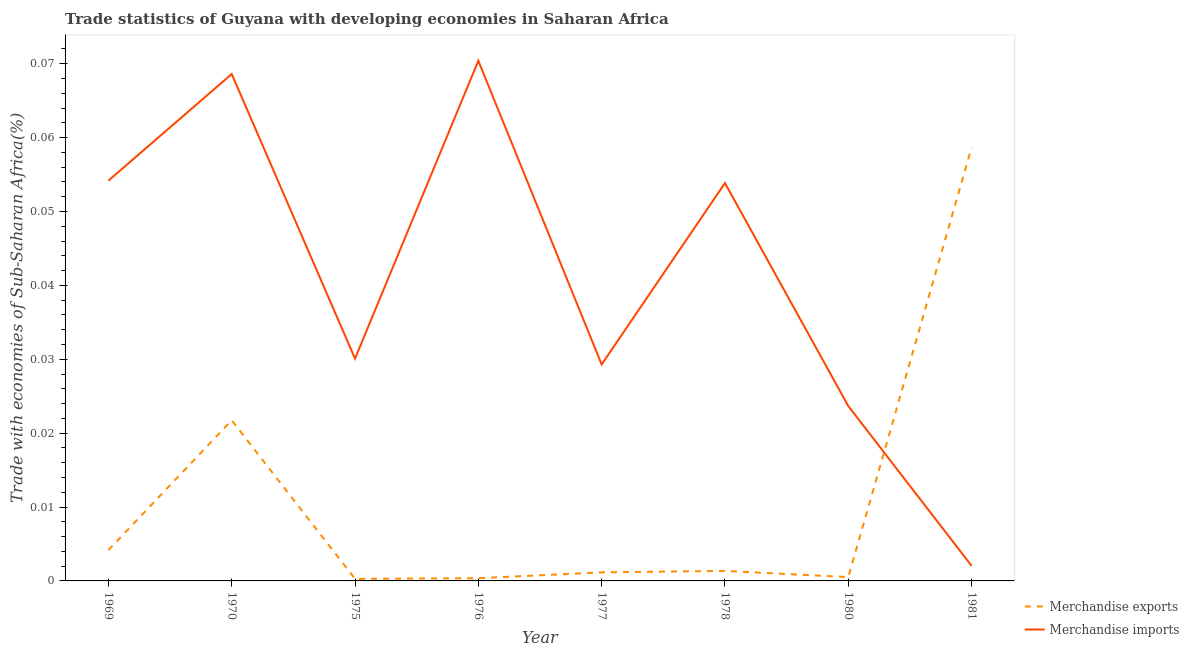Is the number of lines equal to the number of legend labels?
Ensure brevity in your answer.  Yes. What is the merchandise exports in 1981?
Provide a short and direct response. 0.06. Across all years, what is the maximum merchandise imports?
Provide a short and direct response. 0.07. Across all years, what is the minimum merchandise imports?
Your response must be concise. 0. What is the total merchandise imports in the graph?
Your answer should be very brief. 0.33. What is the difference between the merchandise imports in 1969 and that in 1981?
Your response must be concise. 0.05. What is the difference between the merchandise imports in 1975 and the merchandise exports in 1970?
Provide a short and direct response. 0.01. What is the average merchandise imports per year?
Provide a succinct answer. 0.04. In the year 1976, what is the difference between the merchandise exports and merchandise imports?
Ensure brevity in your answer.  -0.07. What is the ratio of the merchandise imports in 1969 to that in 1976?
Keep it short and to the point. 0.77. What is the difference between the highest and the second highest merchandise imports?
Ensure brevity in your answer.  0. What is the difference between the highest and the lowest merchandise imports?
Provide a succinct answer. 0.07. Does the merchandise imports monotonically increase over the years?
Provide a short and direct response. No. Is the merchandise exports strictly less than the merchandise imports over the years?
Provide a succinct answer. No. How many lines are there?
Make the answer very short. 2. How many years are there in the graph?
Your response must be concise. 8. What is the difference between two consecutive major ticks on the Y-axis?
Ensure brevity in your answer.  0.01. Are the values on the major ticks of Y-axis written in scientific E-notation?
Your answer should be compact. No. Does the graph contain any zero values?
Offer a very short reply. No. Does the graph contain grids?
Provide a short and direct response. No. How many legend labels are there?
Keep it short and to the point. 2. What is the title of the graph?
Provide a succinct answer. Trade statistics of Guyana with developing economies in Saharan Africa. What is the label or title of the X-axis?
Your answer should be very brief. Year. What is the label or title of the Y-axis?
Ensure brevity in your answer.  Trade with economies of Sub-Saharan Africa(%). What is the Trade with economies of Sub-Saharan Africa(%) in Merchandise exports in 1969?
Offer a terse response. 0. What is the Trade with economies of Sub-Saharan Africa(%) of Merchandise imports in 1969?
Provide a short and direct response. 0.05. What is the Trade with economies of Sub-Saharan Africa(%) of Merchandise exports in 1970?
Provide a succinct answer. 0.02. What is the Trade with economies of Sub-Saharan Africa(%) of Merchandise imports in 1970?
Ensure brevity in your answer.  0.07. What is the Trade with economies of Sub-Saharan Africa(%) in Merchandise exports in 1975?
Provide a short and direct response. 0. What is the Trade with economies of Sub-Saharan Africa(%) of Merchandise imports in 1975?
Your answer should be compact. 0.03. What is the Trade with economies of Sub-Saharan Africa(%) in Merchandise exports in 1976?
Your answer should be compact. 0. What is the Trade with economies of Sub-Saharan Africa(%) of Merchandise imports in 1976?
Your response must be concise. 0.07. What is the Trade with economies of Sub-Saharan Africa(%) of Merchandise exports in 1977?
Provide a short and direct response. 0. What is the Trade with economies of Sub-Saharan Africa(%) in Merchandise imports in 1977?
Offer a terse response. 0.03. What is the Trade with economies of Sub-Saharan Africa(%) of Merchandise exports in 1978?
Provide a short and direct response. 0. What is the Trade with economies of Sub-Saharan Africa(%) of Merchandise imports in 1978?
Provide a succinct answer. 0.05. What is the Trade with economies of Sub-Saharan Africa(%) in Merchandise exports in 1980?
Your answer should be compact. 0. What is the Trade with economies of Sub-Saharan Africa(%) in Merchandise imports in 1980?
Make the answer very short. 0.02. What is the Trade with economies of Sub-Saharan Africa(%) in Merchandise exports in 1981?
Your answer should be very brief. 0.06. What is the Trade with economies of Sub-Saharan Africa(%) of Merchandise imports in 1981?
Provide a short and direct response. 0. Across all years, what is the maximum Trade with economies of Sub-Saharan Africa(%) of Merchandise exports?
Keep it short and to the point. 0.06. Across all years, what is the maximum Trade with economies of Sub-Saharan Africa(%) in Merchandise imports?
Ensure brevity in your answer.  0.07. Across all years, what is the minimum Trade with economies of Sub-Saharan Africa(%) of Merchandise exports?
Provide a short and direct response. 0. Across all years, what is the minimum Trade with economies of Sub-Saharan Africa(%) in Merchandise imports?
Offer a terse response. 0. What is the total Trade with economies of Sub-Saharan Africa(%) in Merchandise exports in the graph?
Ensure brevity in your answer.  0.09. What is the total Trade with economies of Sub-Saharan Africa(%) in Merchandise imports in the graph?
Provide a short and direct response. 0.33. What is the difference between the Trade with economies of Sub-Saharan Africa(%) in Merchandise exports in 1969 and that in 1970?
Give a very brief answer. -0.02. What is the difference between the Trade with economies of Sub-Saharan Africa(%) of Merchandise imports in 1969 and that in 1970?
Offer a terse response. -0.01. What is the difference between the Trade with economies of Sub-Saharan Africa(%) in Merchandise exports in 1969 and that in 1975?
Offer a terse response. 0. What is the difference between the Trade with economies of Sub-Saharan Africa(%) of Merchandise imports in 1969 and that in 1975?
Ensure brevity in your answer.  0.02. What is the difference between the Trade with economies of Sub-Saharan Africa(%) of Merchandise exports in 1969 and that in 1976?
Make the answer very short. 0. What is the difference between the Trade with economies of Sub-Saharan Africa(%) of Merchandise imports in 1969 and that in 1976?
Make the answer very short. -0.02. What is the difference between the Trade with economies of Sub-Saharan Africa(%) in Merchandise exports in 1969 and that in 1977?
Ensure brevity in your answer.  0. What is the difference between the Trade with economies of Sub-Saharan Africa(%) of Merchandise imports in 1969 and that in 1977?
Make the answer very short. 0.02. What is the difference between the Trade with economies of Sub-Saharan Africa(%) of Merchandise exports in 1969 and that in 1978?
Keep it short and to the point. 0. What is the difference between the Trade with economies of Sub-Saharan Africa(%) of Merchandise imports in 1969 and that in 1978?
Your answer should be very brief. 0. What is the difference between the Trade with economies of Sub-Saharan Africa(%) in Merchandise exports in 1969 and that in 1980?
Keep it short and to the point. 0. What is the difference between the Trade with economies of Sub-Saharan Africa(%) in Merchandise imports in 1969 and that in 1980?
Your answer should be very brief. 0.03. What is the difference between the Trade with economies of Sub-Saharan Africa(%) in Merchandise exports in 1969 and that in 1981?
Your response must be concise. -0.05. What is the difference between the Trade with economies of Sub-Saharan Africa(%) in Merchandise imports in 1969 and that in 1981?
Ensure brevity in your answer.  0.05. What is the difference between the Trade with economies of Sub-Saharan Africa(%) of Merchandise exports in 1970 and that in 1975?
Give a very brief answer. 0.02. What is the difference between the Trade with economies of Sub-Saharan Africa(%) in Merchandise imports in 1970 and that in 1975?
Your response must be concise. 0.04. What is the difference between the Trade with economies of Sub-Saharan Africa(%) of Merchandise exports in 1970 and that in 1976?
Your response must be concise. 0.02. What is the difference between the Trade with economies of Sub-Saharan Africa(%) in Merchandise imports in 1970 and that in 1976?
Make the answer very short. -0. What is the difference between the Trade with economies of Sub-Saharan Africa(%) of Merchandise exports in 1970 and that in 1977?
Your response must be concise. 0.02. What is the difference between the Trade with economies of Sub-Saharan Africa(%) of Merchandise imports in 1970 and that in 1977?
Provide a short and direct response. 0.04. What is the difference between the Trade with economies of Sub-Saharan Africa(%) of Merchandise exports in 1970 and that in 1978?
Ensure brevity in your answer.  0.02. What is the difference between the Trade with economies of Sub-Saharan Africa(%) of Merchandise imports in 1970 and that in 1978?
Give a very brief answer. 0.01. What is the difference between the Trade with economies of Sub-Saharan Africa(%) of Merchandise exports in 1970 and that in 1980?
Ensure brevity in your answer.  0.02. What is the difference between the Trade with economies of Sub-Saharan Africa(%) in Merchandise imports in 1970 and that in 1980?
Your answer should be compact. 0.04. What is the difference between the Trade with economies of Sub-Saharan Africa(%) in Merchandise exports in 1970 and that in 1981?
Your answer should be compact. -0.04. What is the difference between the Trade with economies of Sub-Saharan Africa(%) in Merchandise imports in 1970 and that in 1981?
Provide a short and direct response. 0.07. What is the difference between the Trade with economies of Sub-Saharan Africa(%) of Merchandise exports in 1975 and that in 1976?
Keep it short and to the point. -0. What is the difference between the Trade with economies of Sub-Saharan Africa(%) in Merchandise imports in 1975 and that in 1976?
Your answer should be compact. -0.04. What is the difference between the Trade with economies of Sub-Saharan Africa(%) in Merchandise exports in 1975 and that in 1977?
Your response must be concise. -0. What is the difference between the Trade with economies of Sub-Saharan Africa(%) in Merchandise imports in 1975 and that in 1977?
Provide a short and direct response. 0. What is the difference between the Trade with economies of Sub-Saharan Africa(%) in Merchandise exports in 1975 and that in 1978?
Keep it short and to the point. -0. What is the difference between the Trade with economies of Sub-Saharan Africa(%) in Merchandise imports in 1975 and that in 1978?
Give a very brief answer. -0.02. What is the difference between the Trade with economies of Sub-Saharan Africa(%) of Merchandise exports in 1975 and that in 1980?
Ensure brevity in your answer.  -0. What is the difference between the Trade with economies of Sub-Saharan Africa(%) in Merchandise imports in 1975 and that in 1980?
Make the answer very short. 0.01. What is the difference between the Trade with economies of Sub-Saharan Africa(%) of Merchandise exports in 1975 and that in 1981?
Your response must be concise. -0.06. What is the difference between the Trade with economies of Sub-Saharan Africa(%) of Merchandise imports in 1975 and that in 1981?
Make the answer very short. 0.03. What is the difference between the Trade with economies of Sub-Saharan Africa(%) of Merchandise exports in 1976 and that in 1977?
Offer a terse response. -0. What is the difference between the Trade with economies of Sub-Saharan Africa(%) of Merchandise imports in 1976 and that in 1977?
Your answer should be very brief. 0.04. What is the difference between the Trade with economies of Sub-Saharan Africa(%) in Merchandise exports in 1976 and that in 1978?
Offer a terse response. -0. What is the difference between the Trade with economies of Sub-Saharan Africa(%) in Merchandise imports in 1976 and that in 1978?
Provide a short and direct response. 0.02. What is the difference between the Trade with economies of Sub-Saharan Africa(%) in Merchandise exports in 1976 and that in 1980?
Offer a terse response. -0. What is the difference between the Trade with economies of Sub-Saharan Africa(%) in Merchandise imports in 1976 and that in 1980?
Ensure brevity in your answer.  0.05. What is the difference between the Trade with economies of Sub-Saharan Africa(%) in Merchandise exports in 1976 and that in 1981?
Your answer should be compact. -0.06. What is the difference between the Trade with economies of Sub-Saharan Africa(%) of Merchandise imports in 1976 and that in 1981?
Provide a succinct answer. 0.07. What is the difference between the Trade with economies of Sub-Saharan Africa(%) in Merchandise exports in 1977 and that in 1978?
Give a very brief answer. -0. What is the difference between the Trade with economies of Sub-Saharan Africa(%) of Merchandise imports in 1977 and that in 1978?
Make the answer very short. -0.02. What is the difference between the Trade with economies of Sub-Saharan Africa(%) in Merchandise exports in 1977 and that in 1980?
Offer a very short reply. 0. What is the difference between the Trade with economies of Sub-Saharan Africa(%) of Merchandise imports in 1977 and that in 1980?
Your answer should be compact. 0.01. What is the difference between the Trade with economies of Sub-Saharan Africa(%) of Merchandise exports in 1977 and that in 1981?
Ensure brevity in your answer.  -0.06. What is the difference between the Trade with economies of Sub-Saharan Africa(%) in Merchandise imports in 1977 and that in 1981?
Offer a terse response. 0.03. What is the difference between the Trade with economies of Sub-Saharan Africa(%) in Merchandise exports in 1978 and that in 1980?
Your response must be concise. 0. What is the difference between the Trade with economies of Sub-Saharan Africa(%) of Merchandise imports in 1978 and that in 1980?
Your response must be concise. 0.03. What is the difference between the Trade with economies of Sub-Saharan Africa(%) in Merchandise exports in 1978 and that in 1981?
Your answer should be compact. -0.06. What is the difference between the Trade with economies of Sub-Saharan Africa(%) in Merchandise imports in 1978 and that in 1981?
Ensure brevity in your answer.  0.05. What is the difference between the Trade with economies of Sub-Saharan Africa(%) of Merchandise exports in 1980 and that in 1981?
Your answer should be very brief. -0.06. What is the difference between the Trade with economies of Sub-Saharan Africa(%) in Merchandise imports in 1980 and that in 1981?
Keep it short and to the point. 0.02. What is the difference between the Trade with economies of Sub-Saharan Africa(%) in Merchandise exports in 1969 and the Trade with economies of Sub-Saharan Africa(%) in Merchandise imports in 1970?
Keep it short and to the point. -0.06. What is the difference between the Trade with economies of Sub-Saharan Africa(%) in Merchandise exports in 1969 and the Trade with economies of Sub-Saharan Africa(%) in Merchandise imports in 1975?
Give a very brief answer. -0.03. What is the difference between the Trade with economies of Sub-Saharan Africa(%) in Merchandise exports in 1969 and the Trade with economies of Sub-Saharan Africa(%) in Merchandise imports in 1976?
Provide a succinct answer. -0.07. What is the difference between the Trade with economies of Sub-Saharan Africa(%) in Merchandise exports in 1969 and the Trade with economies of Sub-Saharan Africa(%) in Merchandise imports in 1977?
Your response must be concise. -0.03. What is the difference between the Trade with economies of Sub-Saharan Africa(%) of Merchandise exports in 1969 and the Trade with economies of Sub-Saharan Africa(%) of Merchandise imports in 1978?
Give a very brief answer. -0.05. What is the difference between the Trade with economies of Sub-Saharan Africa(%) of Merchandise exports in 1969 and the Trade with economies of Sub-Saharan Africa(%) of Merchandise imports in 1980?
Keep it short and to the point. -0.02. What is the difference between the Trade with economies of Sub-Saharan Africa(%) in Merchandise exports in 1969 and the Trade with economies of Sub-Saharan Africa(%) in Merchandise imports in 1981?
Your answer should be very brief. 0. What is the difference between the Trade with economies of Sub-Saharan Africa(%) in Merchandise exports in 1970 and the Trade with economies of Sub-Saharan Africa(%) in Merchandise imports in 1975?
Your answer should be compact. -0.01. What is the difference between the Trade with economies of Sub-Saharan Africa(%) of Merchandise exports in 1970 and the Trade with economies of Sub-Saharan Africa(%) of Merchandise imports in 1976?
Your response must be concise. -0.05. What is the difference between the Trade with economies of Sub-Saharan Africa(%) in Merchandise exports in 1970 and the Trade with economies of Sub-Saharan Africa(%) in Merchandise imports in 1977?
Provide a short and direct response. -0.01. What is the difference between the Trade with economies of Sub-Saharan Africa(%) of Merchandise exports in 1970 and the Trade with economies of Sub-Saharan Africa(%) of Merchandise imports in 1978?
Offer a very short reply. -0.03. What is the difference between the Trade with economies of Sub-Saharan Africa(%) in Merchandise exports in 1970 and the Trade with economies of Sub-Saharan Africa(%) in Merchandise imports in 1980?
Ensure brevity in your answer.  -0. What is the difference between the Trade with economies of Sub-Saharan Africa(%) of Merchandise exports in 1970 and the Trade with economies of Sub-Saharan Africa(%) of Merchandise imports in 1981?
Your response must be concise. 0.02. What is the difference between the Trade with economies of Sub-Saharan Africa(%) in Merchandise exports in 1975 and the Trade with economies of Sub-Saharan Africa(%) in Merchandise imports in 1976?
Provide a short and direct response. -0.07. What is the difference between the Trade with economies of Sub-Saharan Africa(%) in Merchandise exports in 1975 and the Trade with economies of Sub-Saharan Africa(%) in Merchandise imports in 1977?
Ensure brevity in your answer.  -0.03. What is the difference between the Trade with economies of Sub-Saharan Africa(%) in Merchandise exports in 1975 and the Trade with economies of Sub-Saharan Africa(%) in Merchandise imports in 1978?
Keep it short and to the point. -0.05. What is the difference between the Trade with economies of Sub-Saharan Africa(%) in Merchandise exports in 1975 and the Trade with economies of Sub-Saharan Africa(%) in Merchandise imports in 1980?
Keep it short and to the point. -0.02. What is the difference between the Trade with economies of Sub-Saharan Africa(%) in Merchandise exports in 1975 and the Trade with economies of Sub-Saharan Africa(%) in Merchandise imports in 1981?
Your answer should be compact. -0. What is the difference between the Trade with economies of Sub-Saharan Africa(%) in Merchandise exports in 1976 and the Trade with economies of Sub-Saharan Africa(%) in Merchandise imports in 1977?
Offer a very short reply. -0.03. What is the difference between the Trade with economies of Sub-Saharan Africa(%) of Merchandise exports in 1976 and the Trade with economies of Sub-Saharan Africa(%) of Merchandise imports in 1978?
Your response must be concise. -0.05. What is the difference between the Trade with economies of Sub-Saharan Africa(%) in Merchandise exports in 1976 and the Trade with economies of Sub-Saharan Africa(%) in Merchandise imports in 1980?
Offer a very short reply. -0.02. What is the difference between the Trade with economies of Sub-Saharan Africa(%) of Merchandise exports in 1976 and the Trade with economies of Sub-Saharan Africa(%) of Merchandise imports in 1981?
Your answer should be very brief. -0. What is the difference between the Trade with economies of Sub-Saharan Africa(%) of Merchandise exports in 1977 and the Trade with economies of Sub-Saharan Africa(%) of Merchandise imports in 1978?
Ensure brevity in your answer.  -0.05. What is the difference between the Trade with economies of Sub-Saharan Africa(%) of Merchandise exports in 1977 and the Trade with economies of Sub-Saharan Africa(%) of Merchandise imports in 1980?
Keep it short and to the point. -0.02. What is the difference between the Trade with economies of Sub-Saharan Africa(%) in Merchandise exports in 1977 and the Trade with economies of Sub-Saharan Africa(%) in Merchandise imports in 1981?
Your response must be concise. -0. What is the difference between the Trade with economies of Sub-Saharan Africa(%) of Merchandise exports in 1978 and the Trade with economies of Sub-Saharan Africa(%) of Merchandise imports in 1980?
Offer a terse response. -0.02. What is the difference between the Trade with economies of Sub-Saharan Africa(%) of Merchandise exports in 1978 and the Trade with economies of Sub-Saharan Africa(%) of Merchandise imports in 1981?
Provide a succinct answer. -0. What is the difference between the Trade with economies of Sub-Saharan Africa(%) of Merchandise exports in 1980 and the Trade with economies of Sub-Saharan Africa(%) of Merchandise imports in 1981?
Give a very brief answer. -0. What is the average Trade with economies of Sub-Saharan Africa(%) of Merchandise exports per year?
Offer a terse response. 0.01. What is the average Trade with economies of Sub-Saharan Africa(%) in Merchandise imports per year?
Provide a succinct answer. 0.04. In the year 1970, what is the difference between the Trade with economies of Sub-Saharan Africa(%) of Merchandise exports and Trade with economies of Sub-Saharan Africa(%) of Merchandise imports?
Provide a succinct answer. -0.05. In the year 1975, what is the difference between the Trade with economies of Sub-Saharan Africa(%) of Merchandise exports and Trade with economies of Sub-Saharan Africa(%) of Merchandise imports?
Give a very brief answer. -0.03. In the year 1976, what is the difference between the Trade with economies of Sub-Saharan Africa(%) of Merchandise exports and Trade with economies of Sub-Saharan Africa(%) of Merchandise imports?
Your response must be concise. -0.07. In the year 1977, what is the difference between the Trade with economies of Sub-Saharan Africa(%) in Merchandise exports and Trade with economies of Sub-Saharan Africa(%) in Merchandise imports?
Offer a terse response. -0.03. In the year 1978, what is the difference between the Trade with economies of Sub-Saharan Africa(%) in Merchandise exports and Trade with economies of Sub-Saharan Africa(%) in Merchandise imports?
Your response must be concise. -0.05. In the year 1980, what is the difference between the Trade with economies of Sub-Saharan Africa(%) in Merchandise exports and Trade with economies of Sub-Saharan Africa(%) in Merchandise imports?
Make the answer very short. -0.02. In the year 1981, what is the difference between the Trade with economies of Sub-Saharan Africa(%) of Merchandise exports and Trade with economies of Sub-Saharan Africa(%) of Merchandise imports?
Your response must be concise. 0.06. What is the ratio of the Trade with economies of Sub-Saharan Africa(%) of Merchandise exports in 1969 to that in 1970?
Give a very brief answer. 0.19. What is the ratio of the Trade with economies of Sub-Saharan Africa(%) in Merchandise imports in 1969 to that in 1970?
Give a very brief answer. 0.79. What is the ratio of the Trade with economies of Sub-Saharan Africa(%) in Merchandise exports in 1969 to that in 1975?
Provide a short and direct response. 15.11. What is the ratio of the Trade with economies of Sub-Saharan Africa(%) of Merchandise imports in 1969 to that in 1975?
Give a very brief answer. 1.8. What is the ratio of the Trade with economies of Sub-Saharan Africa(%) of Merchandise exports in 1969 to that in 1976?
Provide a succinct answer. 11.31. What is the ratio of the Trade with economies of Sub-Saharan Africa(%) of Merchandise imports in 1969 to that in 1976?
Provide a short and direct response. 0.77. What is the ratio of the Trade with economies of Sub-Saharan Africa(%) in Merchandise exports in 1969 to that in 1977?
Give a very brief answer. 3.59. What is the ratio of the Trade with economies of Sub-Saharan Africa(%) of Merchandise imports in 1969 to that in 1977?
Keep it short and to the point. 1.85. What is the ratio of the Trade with economies of Sub-Saharan Africa(%) of Merchandise exports in 1969 to that in 1978?
Keep it short and to the point. 3.07. What is the ratio of the Trade with economies of Sub-Saharan Africa(%) in Merchandise imports in 1969 to that in 1978?
Offer a very short reply. 1.01. What is the ratio of the Trade with economies of Sub-Saharan Africa(%) in Merchandise exports in 1969 to that in 1980?
Offer a terse response. 8.09. What is the ratio of the Trade with economies of Sub-Saharan Africa(%) of Merchandise imports in 1969 to that in 1980?
Provide a succinct answer. 2.29. What is the ratio of the Trade with economies of Sub-Saharan Africa(%) in Merchandise exports in 1969 to that in 1981?
Provide a short and direct response. 0.07. What is the ratio of the Trade with economies of Sub-Saharan Africa(%) in Merchandise imports in 1969 to that in 1981?
Keep it short and to the point. 26.46. What is the ratio of the Trade with economies of Sub-Saharan Africa(%) in Merchandise exports in 1970 to that in 1975?
Ensure brevity in your answer.  78.87. What is the ratio of the Trade with economies of Sub-Saharan Africa(%) of Merchandise imports in 1970 to that in 1975?
Make the answer very short. 2.28. What is the ratio of the Trade with economies of Sub-Saharan Africa(%) in Merchandise exports in 1970 to that in 1976?
Your answer should be compact. 59.04. What is the ratio of the Trade with economies of Sub-Saharan Africa(%) of Merchandise imports in 1970 to that in 1976?
Provide a short and direct response. 0.97. What is the ratio of the Trade with economies of Sub-Saharan Africa(%) in Merchandise exports in 1970 to that in 1977?
Offer a terse response. 18.76. What is the ratio of the Trade with economies of Sub-Saharan Africa(%) of Merchandise imports in 1970 to that in 1977?
Your response must be concise. 2.34. What is the ratio of the Trade with economies of Sub-Saharan Africa(%) in Merchandise exports in 1970 to that in 1978?
Provide a short and direct response. 16.01. What is the ratio of the Trade with economies of Sub-Saharan Africa(%) in Merchandise imports in 1970 to that in 1978?
Your answer should be very brief. 1.27. What is the ratio of the Trade with economies of Sub-Saharan Africa(%) in Merchandise exports in 1970 to that in 1980?
Your answer should be very brief. 42.22. What is the ratio of the Trade with economies of Sub-Saharan Africa(%) in Merchandise imports in 1970 to that in 1980?
Give a very brief answer. 2.9. What is the ratio of the Trade with economies of Sub-Saharan Africa(%) in Merchandise exports in 1970 to that in 1981?
Give a very brief answer. 0.37. What is the ratio of the Trade with economies of Sub-Saharan Africa(%) of Merchandise imports in 1970 to that in 1981?
Ensure brevity in your answer.  33.51. What is the ratio of the Trade with economies of Sub-Saharan Africa(%) in Merchandise exports in 1975 to that in 1976?
Ensure brevity in your answer.  0.75. What is the ratio of the Trade with economies of Sub-Saharan Africa(%) of Merchandise imports in 1975 to that in 1976?
Make the answer very short. 0.43. What is the ratio of the Trade with economies of Sub-Saharan Africa(%) of Merchandise exports in 1975 to that in 1977?
Your answer should be compact. 0.24. What is the ratio of the Trade with economies of Sub-Saharan Africa(%) of Merchandise imports in 1975 to that in 1977?
Offer a terse response. 1.03. What is the ratio of the Trade with economies of Sub-Saharan Africa(%) of Merchandise exports in 1975 to that in 1978?
Make the answer very short. 0.2. What is the ratio of the Trade with economies of Sub-Saharan Africa(%) in Merchandise imports in 1975 to that in 1978?
Make the answer very short. 0.56. What is the ratio of the Trade with economies of Sub-Saharan Africa(%) in Merchandise exports in 1975 to that in 1980?
Make the answer very short. 0.54. What is the ratio of the Trade with economies of Sub-Saharan Africa(%) of Merchandise imports in 1975 to that in 1980?
Provide a short and direct response. 1.27. What is the ratio of the Trade with economies of Sub-Saharan Africa(%) in Merchandise exports in 1975 to that in 1981?
Provide a short and direct response. 0. What is the ratio of the Trade with economies of Sub-Saharan Africa(%) of Merchandise imports in 1975 to that in 1981?
Offer a very short reply. 14.7. What is the ratio of the Trade with economies of Sub-Saharan Africa(%) of Merchandise exports in 1976 to that in 1977?
Your response must be concise. 0.32. What is the ratio of the Trade with economies of Sub-Saharan Africa(%) of Merchandise imports in 1976 to that in 1977?
Your response must be concise. 2.4. What is the ratio of the Trade with economies of Sub-Saharan Africa(%) in Merchandise exports in 1976 to that in 1978?
Your answer should be compact. 0.27. What is the ratio of the Trade with economies of Sub-Saharan Africa(%) of Merchandise imports in 1976 to that in 1978?
Offer a very short reply. 1.31. What is the ratio of the Trade with economies of Sub-Saharan Africa(%) in Merchandise exports in 1976 to that in 1980?
Your answer should be compact. 0.72. What is the ratio of the Trade with economies of Sub-Saharan Africa(%) in Merchandise imports in 1976 to that in 1980?
Your answer should be very brief. 2.97. What is the ratio of the Trade with economies of Sub-Saharan Africa(%) in Merchandise exports in 1976 to that in 1981?
Your response must be concise. 0.01. What is the ratio of the Trade with economies of Sub-Saharan Africa(%) of Merchandise imports in 1976 to that in 1981?
Your answer should be very brief. 34.39. What is the ratio of the Trade with economies of Sub-Saharan Africa(%) of Merchandise exports in 1977 to that in 1978?
Keep it short and to the point. 0.85. What is the ratio of the Trade with economies of Sub-Saharan Africa(%) in Merchandise imports in 1977 to that in 1978?
Offer a terse response. 0.54. What is the ratio of the Trade with economies of Sub-Saharan Africa(%) in Merchandise exports in 1977 to that in 1980?
Provide a short and direct response. 2.25. What is the ratio of the Trade with economies of Sub-Saharan Africa(%) in Merchandise imports in 1977 to that in 1980?
Your response must be concise. 1.24. What is the ratio of the Trade with economies of Sub-Saharan Africa(%) in Merchandise exports in 1977 to that in 1981?
Ensure brevity in your answer.  0.02. What is the ratio of the Trade with economies of Sub-Saharan Africa(%) of Merchandise imports in 1977 to that in 1981?
Offer a terse response. 14.31. What is the ratio of the Trade with economies of Sub-Saharan Africa(%) in Merchandise exports in 1978 to that in 1980?
Provide a short and direct response. 2.64. What is the ratio of the Trade with economies of Sub-Saharan Africa(%) of Merchandise imports in 1978 to that in 1980?
Offer a very short reply. 2.27. What is the ratio of the Trade with economies of Sub-Saharan Africa(%) of Merchandise exports in 1978 to that in 1981?
Provide a short and direct response. 0.02. What is the ratio of the Trade with economies of Sub-Saharan Africa(%) in Merchandise imports in 1978 to that in 1981?
Keep it short and to the point. 26.3. What is the ratio of the Trade with economies of Sub-Saharan Africa(%) in Merchandise exports in 1980 to that in 1981?
Ensure brevity in your answer.  0.01. What is the ratio of the Trade with economies of Sub-Saharan Africa(%) in Merchandise imports in 1980 to that in 1981?
Give a very brief answer. 11.56. What is the difference between the highest and the second highest Trade with economies of Sub-Saharan Africa(%) in Merchandise exports?
Give a very brief answer. 0.04. What is the difference between the highest and the second highest Trade with economies of Sub-Saharan Africa(%) of Merchandise imports?
Offer a very short reply. 0. What is the difference between the highest and the lowest Trade with economies of Sub-Saharan Africa(%) in Merchandise exports?
Make the answer very short. 0.06. What is the difference between the highest and the lowest Trade with economies of Sub-Saharan Africa(%) in Merchandise imports?
Offer a very short reply. 0.07. 